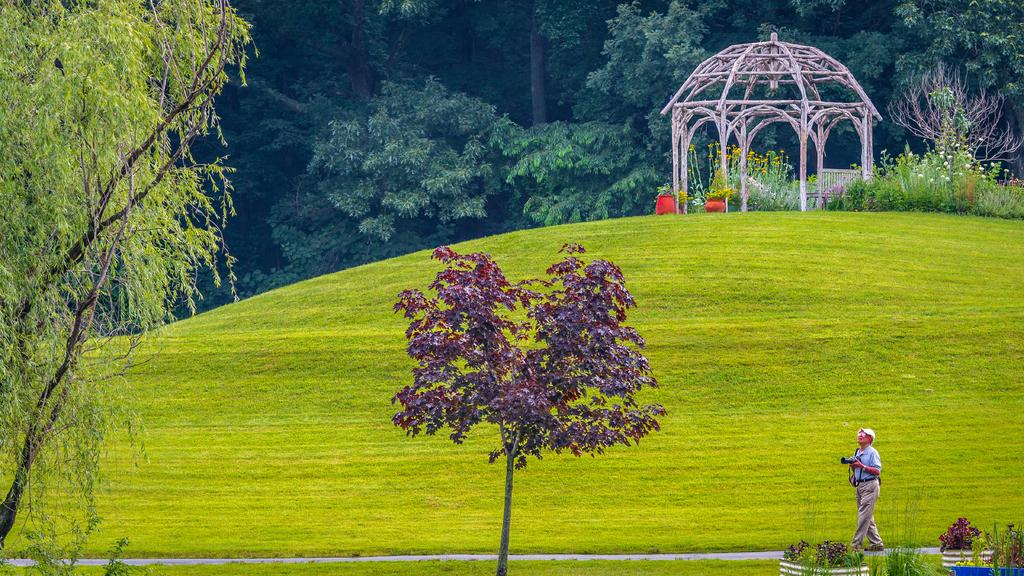What is the person in the image doing? The person is walking in the image. Where is the person walking? The person is walking on a path. What type of vegetation can be seen in the image? There are plants and trees in the image. What is the ground made of in the image? There is grass on the ground in the image. What structure is visible in the background of the image? There is a hut in the background of the image. What type of engine can be seen powering the person's movement in the image? There is no engine present in the image; the person is walking on their own. What type of pipe is visible in the image? There is no pipe present in the image. 